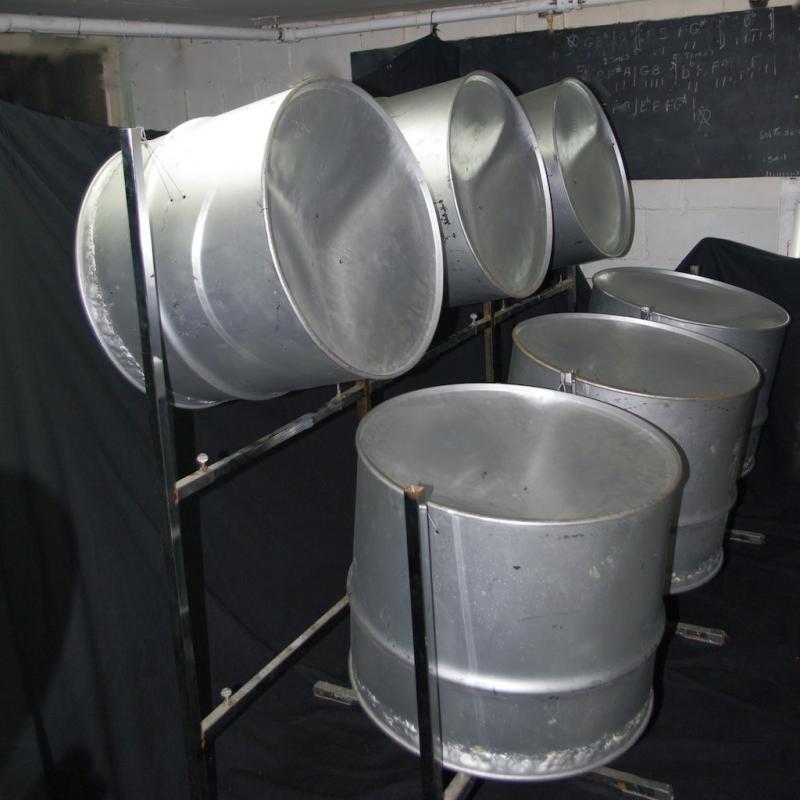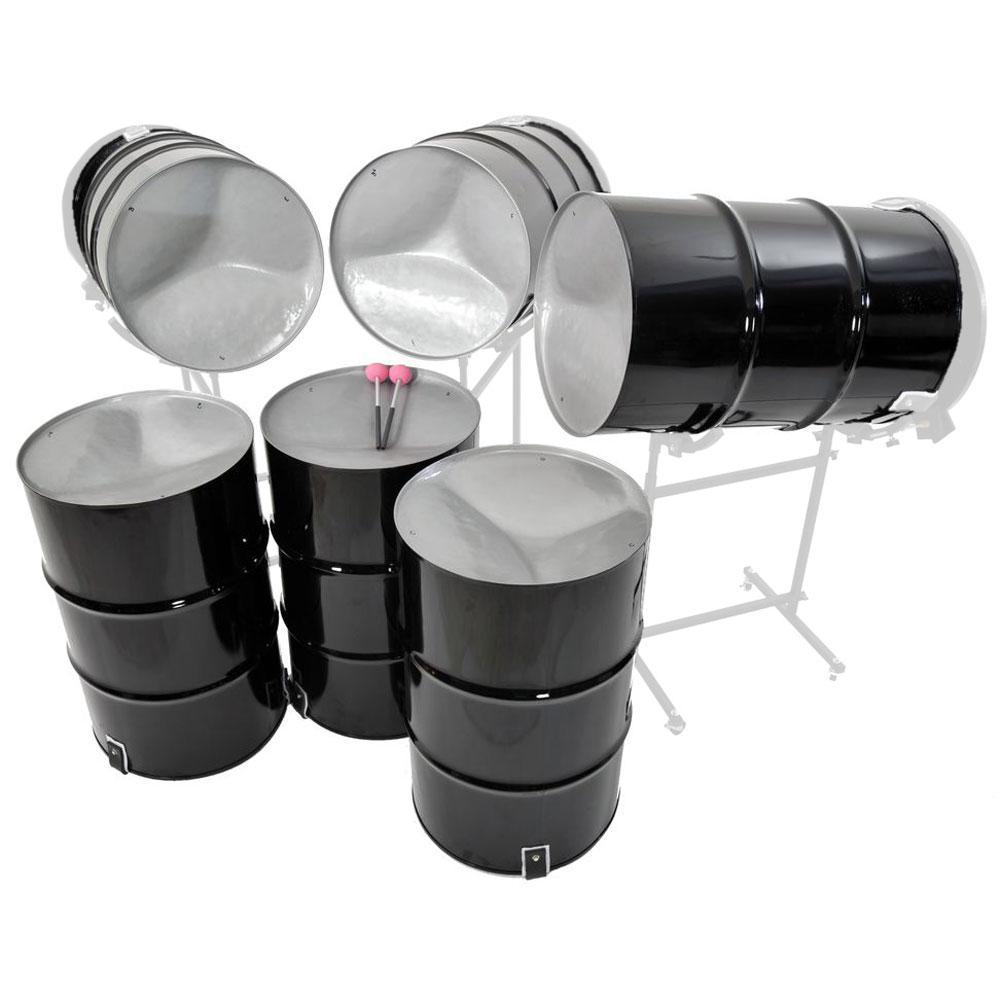The first image is the image on the left, the second image is the image on the right. For the images displayed, is the sentence "There is one image that includes fewer than six drums." factually correct? Answer yes or no. No. The first image is the image on the left, the second image is the image on the right. Considering the images on both sides, is "The right image shows a pair of pink-tipped drumsticks resting on top of the middle of three upright black barrels, which stand in front of three non-upright black barrels." valid? Answer yes or no. Yes. 